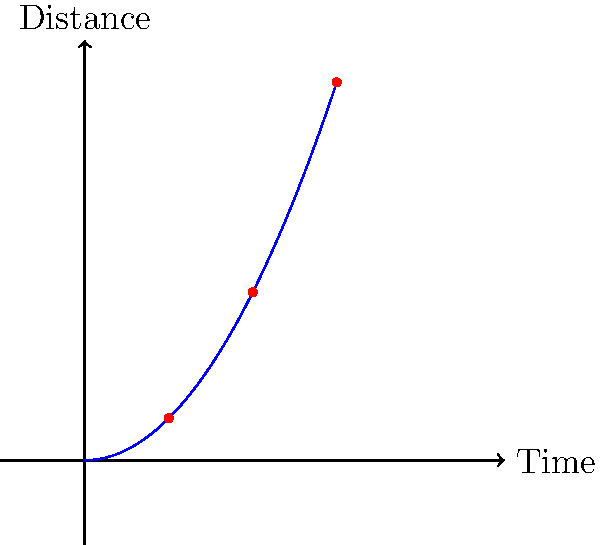Given radar observations of a near-Earth asteroid at three time points (1, 2, and 3 units), the distance from Earth appears to follow a quadratic function. Using machine learning techniques, how would you determine the coefficient of the quadratic term in the asteroid's trajectory equation, assuming it takes the form $d(t) = at^2$ where $d$ is the distance and $t$ is time? To determine the coefficient of the quadratic term, we can use a machine learning approach similar to regression analysis. Here's a step-by-step explanation:

1. Data representation: We have three data points (t, d):
   (1, 0.5), (2, 2), (3, 4.5)

2. Model: We assume the quadratic equation $d(t) = at^2$

3. Loss function: We can use Mean Squared Error (MSE) as our loss function:
   $$MSE = \frac{1}{n}\sum_{i=1}^n (y_i - \hat{y}_i)^2$$
   where $y_i$ are the observed distances and $\hat{y}_i$ are the predicted distances.

4. Gradient descent: We can use gradient descent to minimize the MSE and find the optimal value of $a$. The update rule would be:
   $$a_{new} = a_{old} - \alpha \frac{\partial MSE}{\partial a}$$
   where $\alpha$ is the learning rate.

5. Partial derivative: The partial derivative of MSE with respect to $a$ is:
   $$\frac{\partial MSE}{\partial a} = -\frac{2}{n}\sum_{i=1}^n t_i^2(y_i - at_i^2)$$

6. Implementation: We would iteratively update $a$ using the gradient descent algorithm until convergence.

7. Verification: After finding $a$, we can verify that $d(t) = 0.5t^2$ fits the observed data points.

This machine learning approach allows us to find the coefficient $a$ that best fits the quadratic trajectory based on the radar observations.
Answer: $a = 0.5$ 